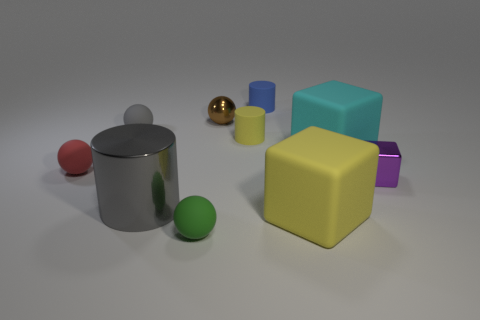Subtract all spheres. How many objects are left? 6 Subtract all large rubber objects. Subtract all red spheres. How many objects are left? 7 Add 6 gray things. How many gray things are left? 8 Add 6 cyan blocks. How many cyan blocks exist? 7 Subtract 0 cyan cylinders. How many objects are left? 10 